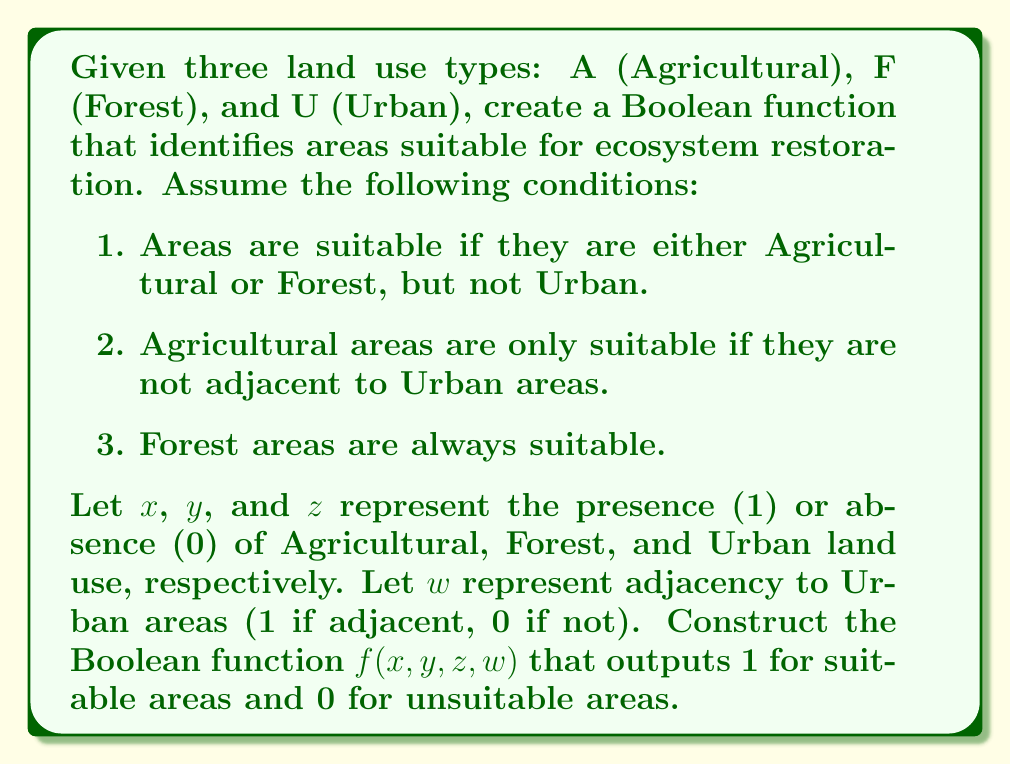Give your solution to this math problem. Let's approach this step-by-step:

1. First, we need to express the conditions in Boolean terms:
   - Suitable areas are (Agricultural OR Forest) AND NOT Urban
   - Agricultural areas are suitable if NOT adjacent to Urban
   - Forest areas are always suitable

2. We can express these conditions using Boolean algebra:
   - Condition 1: $(x \lor y) \land \lnot z$
   - Condition 2 for Agricultural: $x \land \lnot w$
   - Condition 3 for Forest: $y$

3. Combining these conditions, we get:
   $f(x,y,z,w) = [(x \land \lnot w) \lor y] \land \lnot z$

4. We can simplify this expression:
   $f(x,y,z,w) = (x \land \lnot w \land \lnot z) \lor (y \land \lnot z)$

5. This Boolean function will output 1 (suitable) in the following cases:
   - When $x=1$, $w=0$, $z=0$ (Agricultural, not adjacent to Urban, not Urban)
   - When $y=1$, $z=0$ (Forest, not Urban)

6. It will output 0 (unsuitable) in all other cases.

This Boolean function accurately represents the conditions for ecosystem restoration suitability based on the given land use types and adjacency constraints.
Answer: $f(x,y,z,w) = (x \land \lnot w \land \lnot z) \lor (y \land \lnot z)$ 